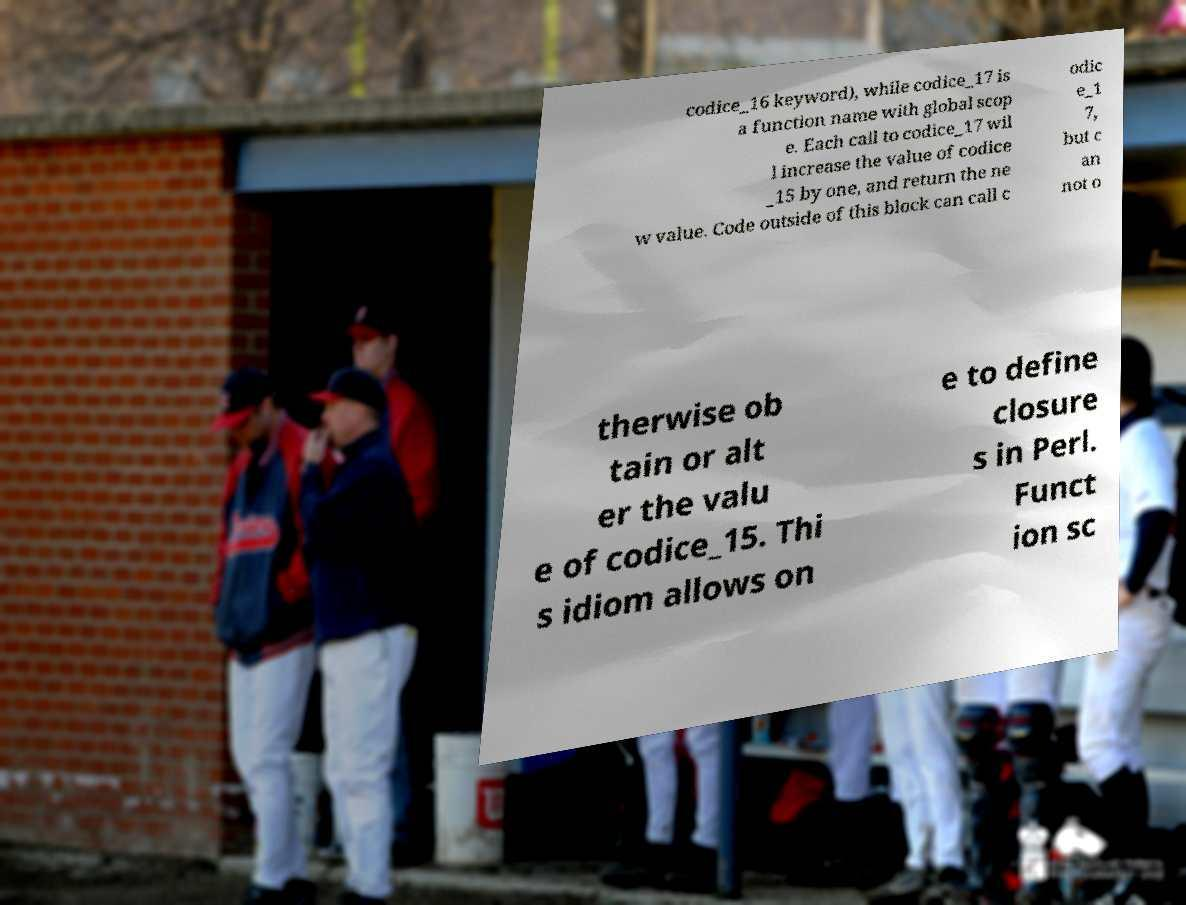Please read and relay the text visible in this image. What does it say? codice_16 keyword), while codice_17 is a function name with global scop e. Each call to codice_17 wil l increase the value of codice _15 by one, and return the ne w value. Code outside of this block can call c odic e_1 7, but c an not o therwise ob tain or alt er the valu e of codice_15. Thi s idiom allows on e to define closure s in Perl. Funct ion sc 